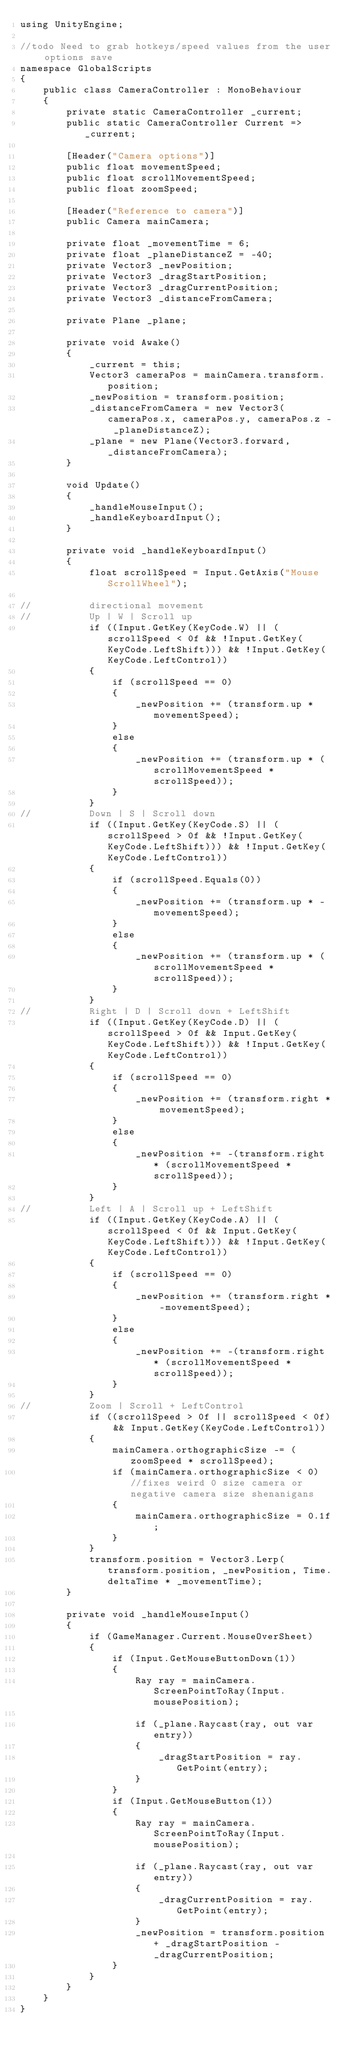Convert code to text. <code><loc_0><loc_0><loc_500><loc_500><_C#_>using UnityEngine;

//todo Need to grab hotkeys/speed values from the user options save
namespace GlobalScripts
{
    public class CameraController : MonoBehaviour
    {
        private static CameraController _current;
        public static CameraController Current => _current;
        
        [Header("Camera options")]
        public float movementSpeed;
        public float scrollMovementSpeed;
        public float zoomSpeed;

        [Header("Reference to camera")]
        public Camera mainCamera;
        
        private float _movementTime = 6;
        private float _planeDistanceZ = -40;
        private Vector3 _newPosition;
        private Vector3 _dragStartPosition;
        private Vector3 _dragCurrentPosition;
        private Vector3 _distanceFromCamera;
        
        private Plane _plane;

        private void Awake()
        {
            _current = this;
            Vector3 cameraPos = mainCamera.transform.position;
            _newPosition = transform.position;
            _distanceFromCamera = new Vector3(cameraPos.x, cameraPos.y, cameraPos.z - _planeDistanceZ);
            _plane = new Plane(Vector3.forward, _distanceFromCamera);
        }

        void Update()
        {
            _handleMouseInput();
            _handleKeyboardInput();
        }

        private void _handleKeyboardInput()
        {
            float scrollSpeed = Input.GetAxis("Mouse ScrollWheel");
            
//          directional movement
//          Up | W | Scroll up
            if ((Input.GetKey(KeyCode.W) || (scrollSpeed < 0f && !Input.GetKey(KeyCode.LeftShift))) && !Input.GetKey(KeyCode.LeftControl))
            {
                if (scrollSpeed == 0)
                {
                    _newPosition += (transform.up * movementSpeed);
                }
                else
                {
                    _newPosition += (transform.up * (scrollMovementSpeed * scrollSpeed));
                }
            }
//          Down | S | Scroll down
            if ((Input.GetKey(KeyCode.S) || (scrollSpeed > 0f && !Input.GetKey(KeyCode.LeftShift))) && !Input.GetKey(KeyCode.LeftControl))
            {
                if (scrollSpeed.Equals(0))
                {
                    _newPosition += (transform.up * -movementSpeed);
                }
                else
                {
                    _newPosition += (transform.up * (scrollMovementSpeed * scrollSpeed));
                }
            }
//          Right | D | Scroll down + LeftShift
            if ((Input.GetKey(KeyCode.D) || (scrollSpeed > 0f && Input.GetKey(KeyCode.LeftShift))) && !Input.GetKey(KeyCode.LeftControl))
            {
                if (scrollSpeed == 0)
                {
                    _newPosition += (transform.right * movementSpeed);
                }
                else
                {
                    _newPosition += -(transform.right * (scrollMovementSpeed * scrollSpeed));
                }
            }
//          Left | A | Scroll up + LeftShift
            if ((Input.GetKey(KeyCode.A) || (scrollSpeed < 0f && Input.GetKey(KeyCode.LeftShift))) && !Input.GetKey(KeyCode.LeftControl))
            {
                if (scrollSpeed == 0)
                {
                    _newPosition += (transform.right * -movementSpeed);
                }
                else
                {
                    _newPosition += -(transform.right * (scrollMovementSpeed * scrollSpeed));
                }
            }
//          Zoom | Scroll + LeftControl
            if ((scrollSpeed > 0f || scrollSpeed < 0f) && Input.GetKey(KeyCode.LeftControl))
            {
                mainCamera.orthographicSize -= (zoomSpeed * scrollSpeed);
                if (mainCamera.orthographicSize < 0) //fixes weird 0 size camera or negative camera size shenanigans
                {
                    mainCamera.orthographicSize = 0.1f;
                }
            }
            transform.position = Vector3.Lerp(transform.position, _newPosition, Time.deltaTime * _movementTime);
        }

        private void _handleMouseInput()
        {
            if (GameManager.Current.MouseOverSheet)
            {
                if (Input.GetMouseButtonDown(1))
                {
                    Ray ray = mainCamera.ScreenPointToRay(Input.mousePosition);

                    if (_plane.Raycast(ray, out var entry))
                    {
                        _dragStartPosition = ray.GetPoint(entry);
                    }
                }
                if (Input.GetMouseButton(1))
                {
                    Ray ray = mainCamera.ScreenPointToRay(Input.mousePosition);

                    if (_plane.Raycast(ray, out var entry))
                    {
                        _dragCurrentPosition = ray.GetPoint(entry);
                    }
                    _newPosition = transform.position + _dragStartPosition - _dragCurrentPosition;
                }   
            }
        }
    }
}
</code> 